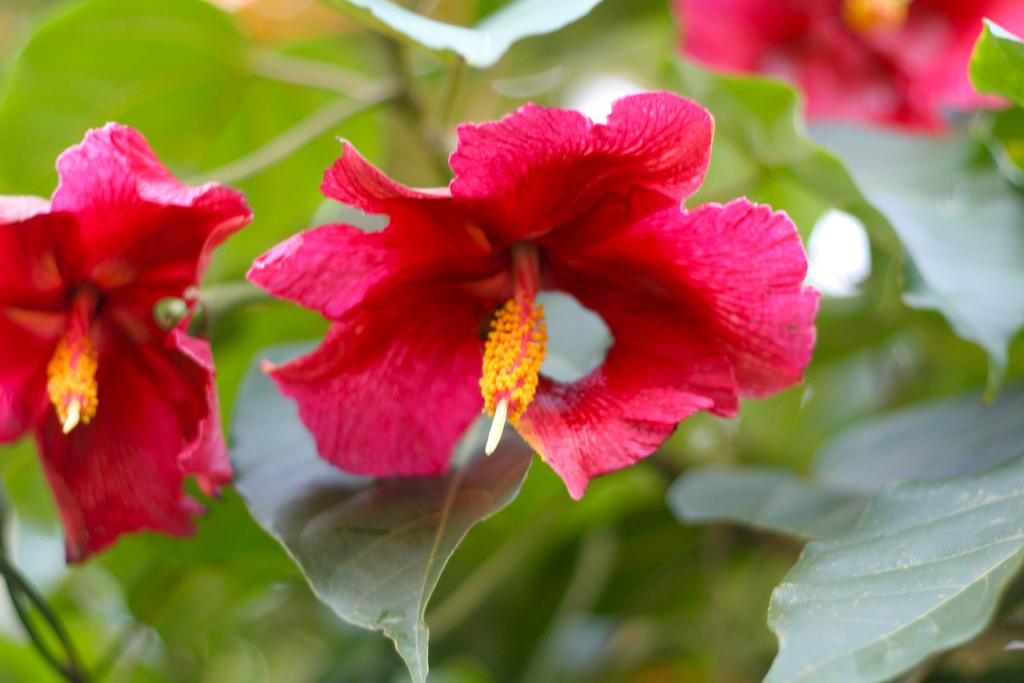What type of living organisms can be seen in the image? There are flowers in the image. What colors are the flowers? The flowers are pink, red, and yellow in color. What is the flowers' location on in the image? The flowers are on a plant. What color is the plant? The plant is green in color. Can you describe the background of the image? The background of the image is blurry. How many chairs are visible in the image? There are no chairs present in the image; it features flowers on a plant. 